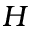<formula> <loc_0><loc_0><loc_500><loc_500>H</formula> 